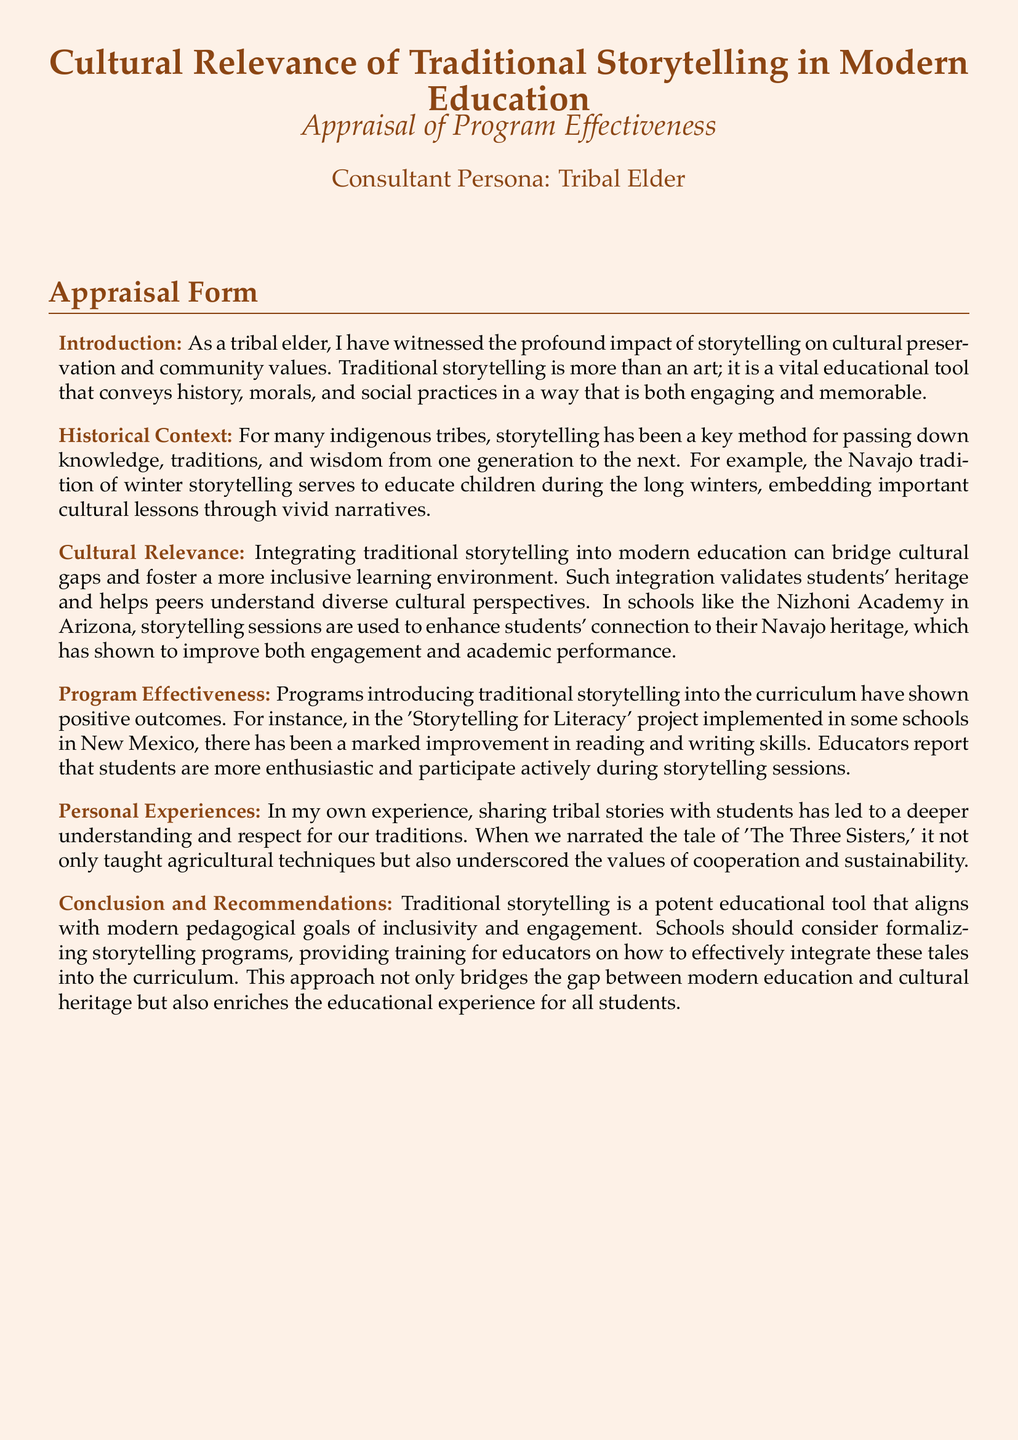What is the title of the document? The title of the document is given at the beginning and is clearly stated.
Answer: Cultural Relevance of Traditional Storytelling in Modern Education Who is the consultant persona? The consultant persona is mentioned in the document as the individual providing insights and experiences.
Answer: Tribal Elder What program showed marked improvement in reading and writing skills? The document mentions a specific project that produced positive outcomes in literacy.
Answer: Storytelling for Literacy Where is the Nizhoni Academy located? The document specifies the location of the academy that uses storytelling in its curriculum.
Answer: Arizona What lesson is conveyed by the tale of 'The Three Sisters'? The document describes the values taught through this traditional story, emphasizing its significance.
Answer: Cooperation and sustainability How has storytelling been integrated in schools? The document discusses a method by which traditional storytelling is formally included in the curriculum.
Answer: Storytelling programs What does the consultant recommend for schools? The recommendations made by the consultant are aimed at enhancing educational practices.
Answer: Formalizing storytelling programs During what season do Navajo children learn through storytelling? The document provides a specific time frame related to the storytelling tradition among Navajo children.
Answer: Winter 